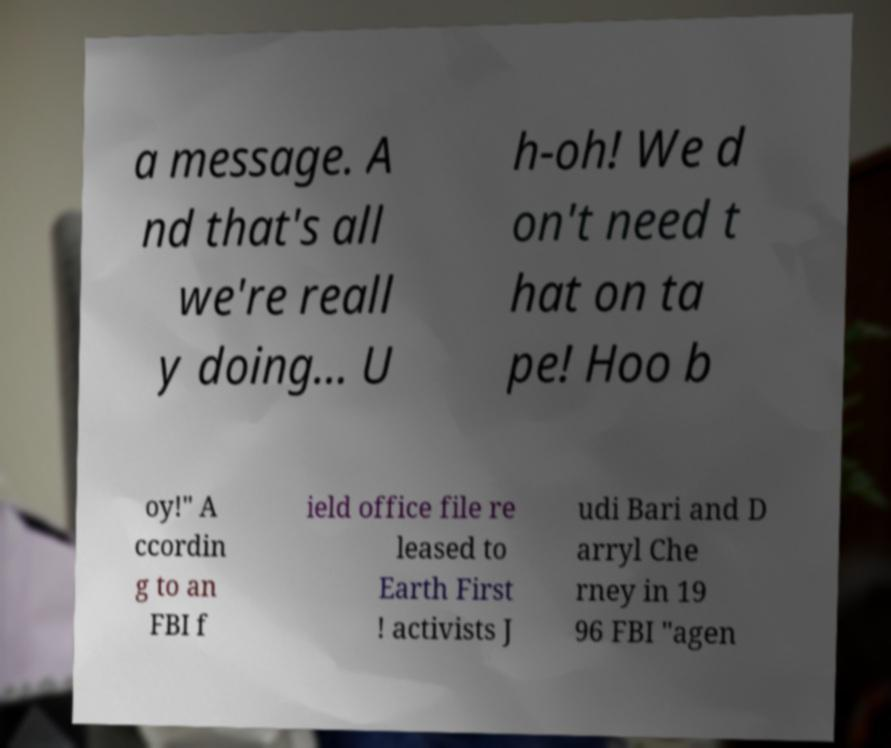Can you read and provide the text displayed in the image?This photo seems to have some interesting text. Can you extract and type it out for me? a message. A nd that's all we're reall y doing... U h-oh! We d on't need t hat on ta pe! Hoo b oy!" A ccordin g to an FBI f ield office file re leased to Earth First ! activists J udi Bari and D arryl Che rney in 19 96 FBI "agen 